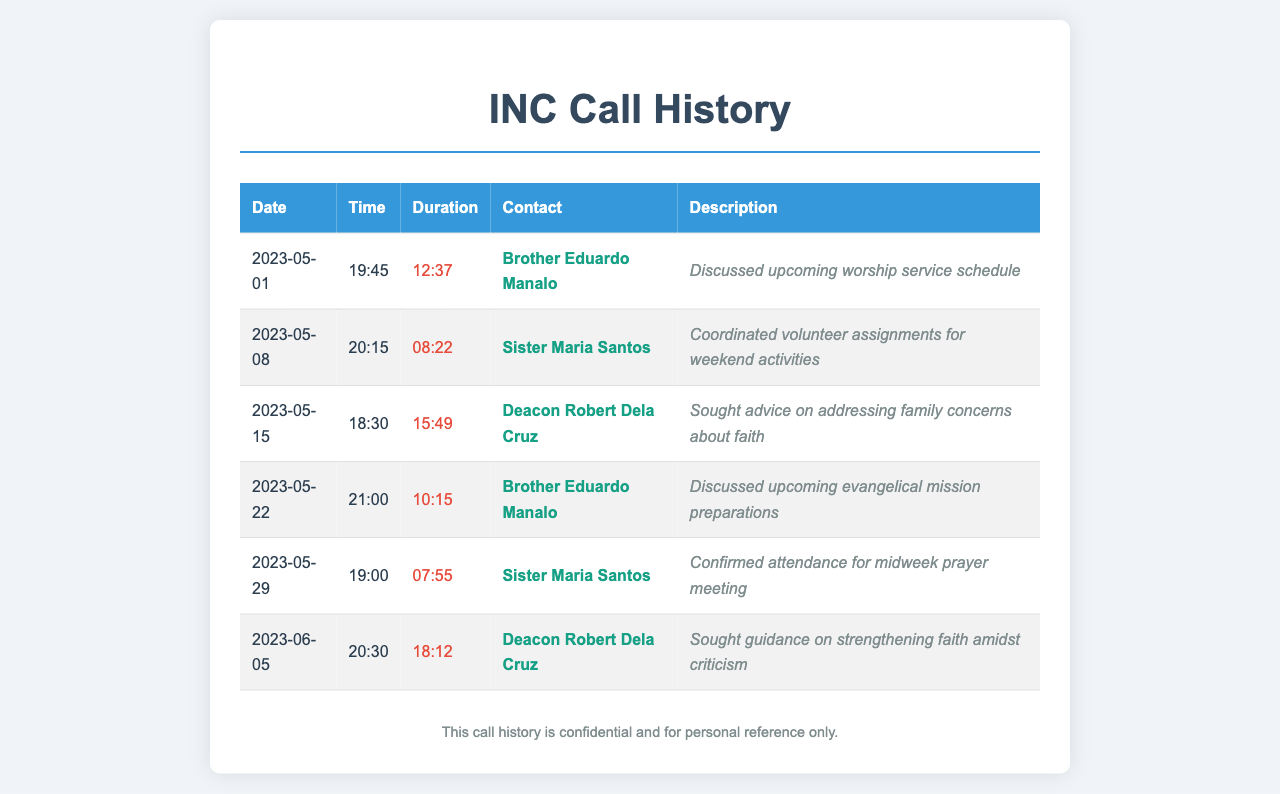what is the date of the first call? The first call in the document is dated May 1, 2023.
Answer: May 1, 2023 who is the contact for the longest call? The longest call was with Deacon Robert Dela Cruz, lasting 18 minutes and 12 seconds.
Answer: Deacon Robert Dela Cruz how many calls were made to Sister Maria Santos? There are two calls recorded to Sister Maria Santos in the document.
Answer: 2 what was discussed in the call on May 15, 2023? The call on May 15, 2023, involved seeking advice on addressing family concerns about faith.
Answer: Sought advice on addressing family concerns about faith which Brother is mentioned twice in the call history? Brother Eduardo Manalo is mentioned in two different calls in the document.
Answer: Brother Eduardo Manalo what time did the call on June 5, 2023 take place? The call on June 5, 2023, occurred at 20:30.
Answer: 20:30 what is the total duration of calls made to Deacon Robert Dela Cruz? The total duration for calls to Deacon Robert Dela Cruz is 15 minutes and 49 seconds plus 18 minutes and 12 seconds, amounting to 34 minutes and 1 second.
Answer: 34:01 how many calls were made in total? The total number of calls recorded in the document is six.
Answer: 6 